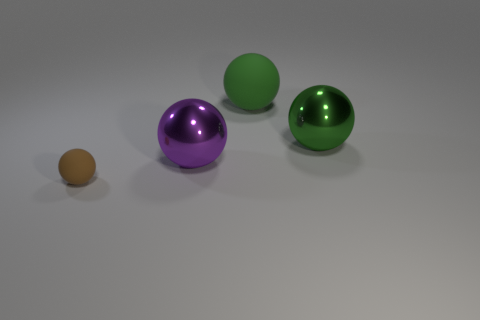Subtract 1 spheres. How many spheres are left? 3 Add 3 small objects. How many objects exist? 7 Subtract all green balls. Subtract all green objects. How many objects are left? 0 Add 3 big shiny balls. How many big shiny balls are left? 5 Add 4 red shiny cylinders. How many red shiny cylinders exist? 4 Subtract 0 yellow cylinders. How many objects are left? 4 